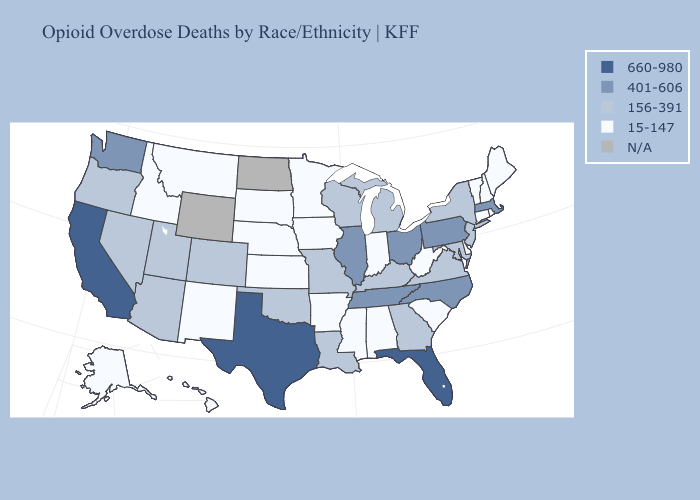Name the states that have a value in the range 156-391?
Keep it brief. Arizona, Colorado, Georgia, Kentucky, Louisiana, Maryland, Michigan, Missouri, Nevada, New Jersey, New York, Oklahoma, Oregon, Utah, Virginia, Wisconsin. Does Oklahoma have the highest value in the USA?
Write a very short answer. No. Name the states that have a value in the range 156-391?
Keep it brief. Arizona, Colorado, Georgia, Kentucky, Louisiana, Maryland, Michigan, Missouri, Nevada, New Jersey, New York, Oklahoma, Oregon, Utah, Virginia, Wisconsin. What is the value of Nevada?
Keep it brief. 156-391. What is the value of Texas?
Give a very brief answer. 660-980. Does Arkansas have the highest value in the USA?
Keep it brief. No. What is the highest value in the USA?
Quick response, please. 660-980. Which states have the highest value in the USA?
Answer briefly. California, Florida, Texas. What is the value of Minnesota?
Quick response, please. 15-147. What is the value of Pennsylvania?
Concise answer only. 401-606. What is the value of South Dakota?
Be succinct. 15-147. Name the states that have a value in the range 15-147?
Answer briefly. Alabama, Alaska, Arkansas, Connecticut, Delaware, Hawaii, Idaho, Indiana, Iowa, Kansas, Maine, Minnesota, Mississippi, Montana, Nebraska, New Hampshire, New Mexico, Rhode Island, South Carolina, South Dakota, Vermont, West Virginia. What is the highest value in the USA?
Give a very brief answer. 660-980. Name the states that have a value in the range 660-980?
Write a very short answer. California, Florida, Texas. 